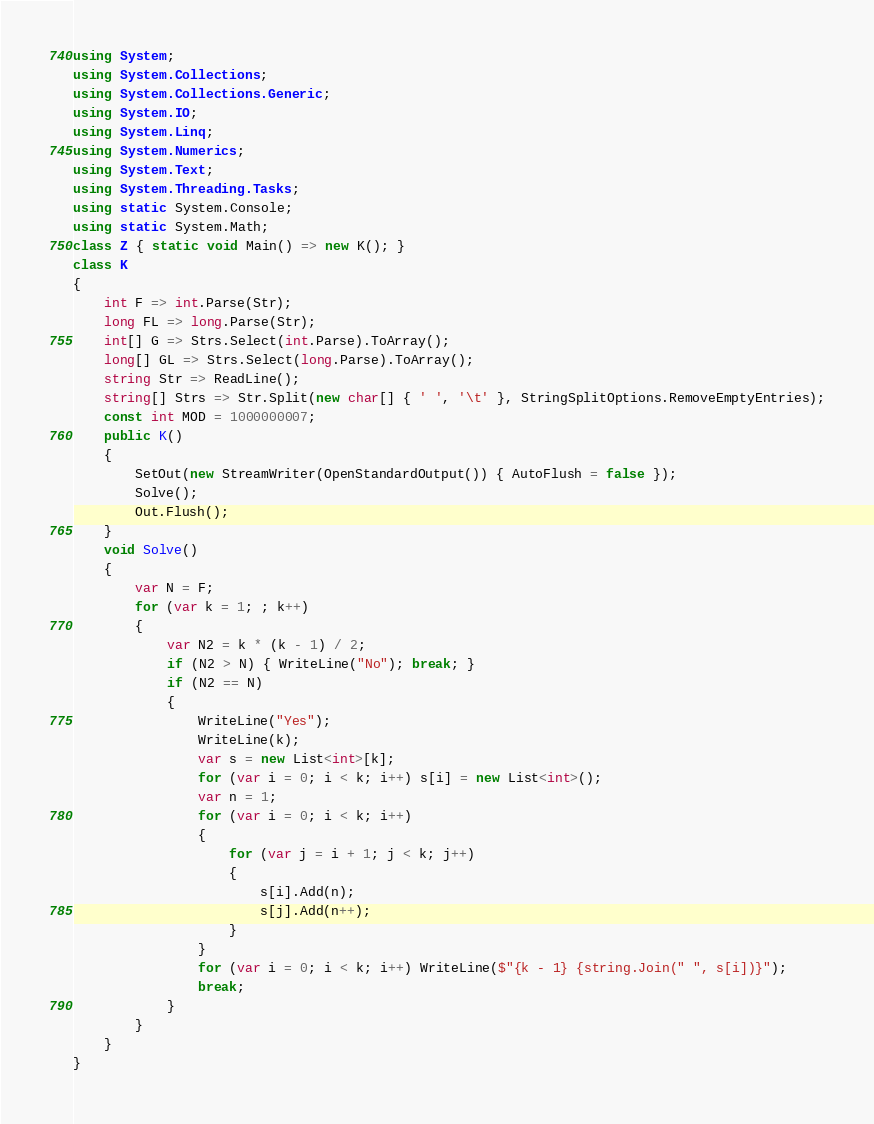<code> <loc_0><loc_0><loc_500><loc_500><_C#_>using System;
using System.Collections;
using System.Collections.Generic;
using System.IO;
using System.Linq;
using System.Numerics;
using System.Text;
using System.Threading.Tasks;
using static System.Console;
using static System.Math;
class Z { static void Main() => new K(); }
class K
{
	int F => int.Parse(Str);
	long FL => long.Parse(Str);
	int[] G => Strs.Select(int.Parse).ToArray();
	long[] GL => Strs.Select(long.Parse).ToArray();
	string Str => ReadLine();
	string[] Strs => Str.Split(new char[] { ' ', '\t' }, StringSplitOptions.RemoveEmptyEntries);
	const int MOD = 1000000007;
	public K()
	{
		SetOut(new StreamWriter(OpenStandardOutput()) { AutoFlush = false });
		Solve();
		Out.Flush();
	}
	void Solve()
	{
		var N = F;
		for (var k = 1; ; k++)
		{
			var N2 = k * (k - 1) / 2;
			if (N2 > N) { WriteLine("No"); break; }
			if (N2 == N)
			{
				WriteLine("Yes");
				WriteLine(k);
				var s = new List<int>[k];
				for (var i = 0; i < k; i++) s[i] = new List<int>();
				var n = 1;
				for (var i = 0; i < k; i++)
				{
					for (var j = i + 1; j < k; j++)
					{
						s[i].Add(n);
						s[j].Add(n++);
					}
				}
				for (var i = 0; i < k; i++) WriteLine($"{k - 1} {string.Join(" ", s[i])}");
				break;
			}
		}
	}
}
</code> 